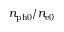Convert formula to latex. <formula><loc_0><loc_0><loc_500><loc_500>n _ { p h 0 } / n _ { e 0 }</formula> 